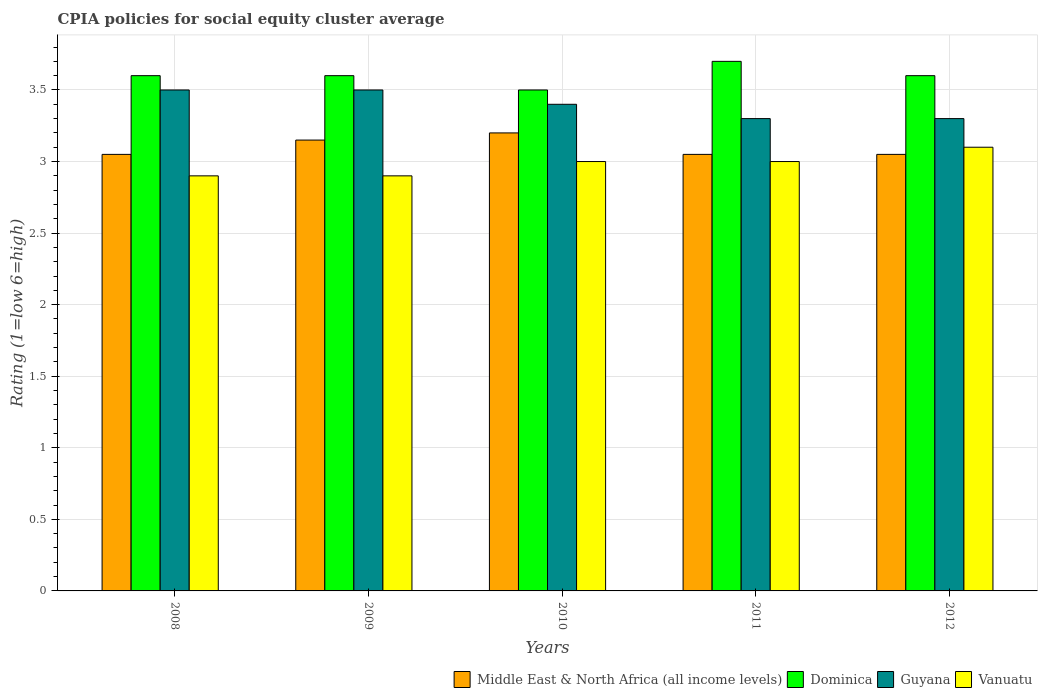How many groups of bars are there?
Your answer should be compact. 5. Are the number of bars on each tick of the X-axis equal?
Keep it short and to the point. Yes. How many bars are there on the 1st tick from the right?
Ensure brevity in your answer.  4. In how many cases, is the number of bars for a given year not equal to the number of legend labels?
Ensure brevity in your answer.  0. What is the CPIA rating in Middle East & North Africa (all income levels) in 2008?
Ensure brevity in your answer.  3.05. In which year was the CPIA rating in Middle East & North Africa (all income levels) minimum?
Your answer should be compact. 2008. What is the difference between the CPIA rating in Vanuatu in 2010 and that in 2011?
Your response must be concise. 0. What is the difference between the CPIA rating in Dominica in 2009 and the CPIA rating in Guyana in 2012?
Give a very brief answer. 0.3. In the year 2011, what is the difference between the CPIA rating in Dominica and CPIA rating in Middle East & North Africa (all income levels)?
Give a very brief answer. 0.65. In how many years, is the CPIA rating in Vanuatu greater than 1.6?
Give a very brief answer. 5. What is the ratio of the CPIA rating in Dominica in 2008 to that in 2009?
Offer a very short reply. 1. Is the CPIA rating in Dominica in 2008 less than that in 2011?
Make the answer very short. Yes. Is the difference between the CPIA rating in Dominica in 2010 and 2012 greater than the difference between the CPIA rating in Middle East & North Africa (all income levels) in 2010 and 2012?
Your answer should be compact. No. What is the difference between the highest and the lowest CPIA rating in Dominica?
Your response must be concise. 0.2. In how many years, is the CPIA rating in Guyana greater than the average CPIA rating in Guyana taken over all years?
Your response must be concise. 2. Is the sum of the CPIA rating in Dominica in 2011 and 2012 greater than the maximum CPIA rating in Middle East & North Africa (all income levels) across all years?
Provide a succinct answer. Yes. Is it the case that in every year, the sum of the CPIA rating in Dominica and CPIA rating in Vanuatu is greater than the sum of CPIA rating in Middle East & North Africa (all income levels) and CPIA rating in Guyana?
Give a very brief answer. Yes. What does the 4th bar from the left in 2011 represents?
Your response must be concise. Vanuatu. What does the 4th bar from the right in 2008 represents?
Offer a terse response. Middle East & North Africa (all income levels). How many bars are there?
Give a very brief answer. 20. Are all the bars in the graph horizontal?
Offer a terse response. No. How many years are there in the graph?
Keep it short and to the point. 5. What is the difference between two consecutive major ticks on the Y-axis?
Your answer should be compact. 0.5. How many legend labels are there?
Offer a very short reply. 4. What is the title of the graph?
Offer a very short reply. CPIA policies for social equity cluster average. Does "Estonia" appear as one of the legend labels in the graph?
Keep it short and to the point. No. What is the label or title of the X-axis?
Your answer should be very brief. Years. What is the Rating (1=low 6=high) of Middle East & North Africa (all income levels) in 2008?
Your answer should be compact. 3.05. What is the Rating (1=low 6=high) of Guyana in 2008?
Provide a short and direct response. 3.5. What is the Rating (1=low 6=high) of Middle East & North Africa (all income levels) in 2009?
Offer a very short reply. 3.15. What is the Rating (1=low 6=high) of Dominica in 2009?
Keep it short and to the point. 3.6. What is the Rating (1=low 6=high) in Vanuatu in 2009?
Keep it short and to the point. 2.9. What is the Rating (1=low 6=high) in Guyana in 2010?
Provide a short and direct response. 3.4. What is the Rating (1=low 6=high) in Middle East & North Africa (all income levels) in 2011?
Offer a terse response. 3.05. What is the Rating (1=low 6=high) in Dominica in 2011?
Provide a short and direct response. 3.7. What is the Rating (1=low 6=high) in Guyana in 2011?
Make the answer very short. 3.3. What is the Rating (1=low 6=high) in Middle East & North Africa (all income levels) in 2012?
Ensure brevity in your answer.  3.05. What is the Rating (1=low 6=high) in Guyana in 2012?
Your answer should be very brief. 3.3. What is the Rating (1=low 6=high) in Vanuatu in 2012?
Ensure brevity in your answer.  3.1. Across all years, what is the maximum Rating (1=low 6=high) of Guyana?
Ensure brevity in your answer.  3.5. Across all years, what is the minimum Rating (1=low 6=high) of Middle East & North Africa (all income levels)?
Offer a very short reply. 3.05. Across all years, what is the minimum Rating (1=low 6=high) in Dominica?
Your answer should be very brief. 3.5. Across all years, what is the minimum Rating (1=low 6=high) in Guyana?
Provide a short and direct response. 3.3. What is the total Rating (1=low 6=high) in Dominica in the graph?
Your answer should be compact. 18. What is the total Rating (1=low 6=high) of Vanuatu in the graph?
Ensure brevity in your answer.  14.9. What is the difference between the Rating (1=low 6=high) in Guyana in 2008 and that in 2009?
Keep it short and to the point. 0. What is the difference between the Rating (1=low 6=high) in Vanuatu in 2008 and that in 2009?
Make the answer very short. 0. What is the difference between the Rating (1=low 6=high) in Dominica in 2008 and that in 2010?
Offer a very short reply. 0.1. What is the difference between the Rating (1=low 6=high) of Vanuatu in 2008 and that in 2010?
Your answer should be very brief. -0.1. What is the difference between the Rating (1=low 6=high) in Dominica in 2008 and that in 2011?
Your answer should be very brief. -0.1. What is the difference between the Rating (1=low 6=high) of Dominica in 2008 and that in 2012?
Your answer should be compact. 0. What is the difference between the Rating (1=low 6=high) of Vanuatu in 2008 and that in 2012?
Offer a very short reply. -0.2. What is the difference between the Rating (1=low 6=high) in Middle East & North Africa (all income levels) in 2009 and that in 2010?
Make the answer very short. -0.05. What is the difference between the Rating (1=low 6=high) of Vanuatu in 2009 and that in 2010?
Your answer should be very brief. -0.1. What is the difference between the Rating (1=low 6=high) in Guyana in 2009 and that in 2011?
Your response must be concise. 0.2. What is the difference between the Rating (1=low 6=high) of Vanuatu in 2009 and that in 2011?
Keep it short and to the point. -0.1. What is the difference between the Rating (1=low 6=high) in Middle East & North Africa (all income levels) in 2009 and that in 2012?
Your response must be concise. 0.1. What is the difference between the Rating (1=low 6=high) of Dominica in 2009 and that in 2012?
Make the answer very short. 0. What is the difference between the Rating (1=low 6=high) of Guyana in 2009 and that in 2012?
Offer a very short reply. 0.2. What is the difference between the Rating (1=low 6=high) in Dominica in 2010 and that in 2011?
Offer a terse response. -0.2. What is the difference between the Rating (1=low 6=high) of Guyana in 2010 and that in 2011?
Offer a very short reply. 0.1. What is the difference between the Rating (1=low 6=high) in Vanuatu in 2010 and that in 2011?
Give a very brief answer. 0. What is the difference between the Rating (1=low 6=high) of Middle East & North Africa (all income levels) in 2010 and that in 2012?
Your response must be concise. 0.15. What is the difference between the Rating (1=low 6=high) in Guyana in 2010 and that in 2012?
Offer a terse response. 0.1. What is the difference between the Rating (1=low 6=high) of Middle East & North Africa (all income levels) in 2011 and that in 2012?
Provide a short and direct response. 0. What is the difference between the Rating (1=low 6=high) in Dominica in 2011 and that in 2012?
Your answer should be compact. 0.1. What is the difference between the Rating (1=low 6=high) in Guyana in 2011 and that in 2012?
Ensure brevity in your answer.  0. What is the difference between the Rating (1=low 6=high) in Vanuatu in 2011 and that in 2012?
Ensure brevity in your answer.  -0.1. What is the difference between the Rating (1=low 6=high) of Middle East & North Africa (all income levels) in 2008 and the Rating (1=low 6=high) of Dominica in 2009?
Provide a short and direct response. -0.55. What is the difference between the Rating (1=low 6=high) in Middle East & North Africa (all income levels) in 2008 and the Rating (1=low 6=high) in Guyana in 2009?
Offer a very short reply. -0.45. What is the difference between the Rating (1=low 6=high) in Dominica in 2008 and the Rating (1=low 6=high) in Guyana in 2009?
Your response must be concise. 0.1. What is the difference between the Rating (1=low 6=high) in Dominica in 2008 and the Rating (1=low 6=high) in Vanuatu in 2009?
Ensure brevity in your answer.  0.7. What is the difference between the Rating (1=low 6=high) of Middle East & North Africa (all income levels) in 2008 and the Rating (1=low 6=high) of Dominica in 2010?
Ensure brevity in your answer.  -0.45. What is the difference between the Rating (1=low 6=high) in Middle East & North Africa (all income levels) in 2008 and the Rating (1=low 6=high) in Guyana in 2010?
Your answer should be compact. -0.35. What is the difference between the Rating (1=low 6=high) of Dominica in 2008 and the Rating (1=low 6=high) of Vanuatu in 2010?
Give a very brief answer. 0.6. What is the difference between the Rating (1=low 6=high) in Guyana in 2008 and the Rating (1=low 6=high) in Vanuatu in 2010?
Your answer should be very brief. 0.5. What is the difference between the Rating (1=low 6=high) of Middle East & North Africa (all income levels) in 2008 and the Rating (1=low 6=high) of Dominica in 2011?
Your answer should be very brief. -0.65. What is the difference between the Rating (1=low 6=high) of Middle East & North Africa (all income levels) in 2008 and the Rating (1=low 6=high) of Guyana in 2011?
Provide a short and direct response. -0.25. What is the difference between the Rating (1=low 6=high) of Dominica in 2008 and the Rating (1=low 6=high) of Vanuatu in 2011?
Offer a very short reply. 0.6. What is the difference between the Rating (1=low 6=high) in Middle East & North Africa (all income levels) in 2008 and the Rating (1=low 6=high) in Dominica in 2012?
Provide a short and direct response. -0.55. What is the difference between the Rating (1=low 6=high) in Middle East & North Africa (all income levels) in 2008 and the Rating (1=low 6=high) in Vanuatu in 2012?
Your answer should be very brief. -0.05. What is the difference between the Rating (1=low 6=high) of Guyana in 2008 and the Rating (1=low 6=high) of Vanuatu in 2012?
Make the answer very short. 0.4. What is the difference between the Rating (1=low 6=high) in Middle East & North Africa (all income levels) in 2009 and the Rating (1=low 6=high) in Dominica in 2010?
Provide a succinct answer. -0.35. What is the difference between the Rating (1=low 6=high) in Middle East & North Africa (all income levels) in 2009 and the Rating (1=low 6=high) in Vanuatu in 2010?
Your answer should be very brief. 0.15. What is the difference between the Rating (1=low 6=high) of Middle East & North Africa (all income levels) in 2009 and the Rating (1=low 6=high) of Dominica in 2011?
Ensure brevity in your answer.  -0.55. What is the difference between the Rating (1=low 6=high) in Guyana in 2009 and the Rating (1=low 6=high) in Vanuatu in 2011?
Keep it short and to the point. 0.5. What is the difference between the Rating (1=low 6=high) in Middle East & North Africa (all income levels) in 2009 and the Rating (1=low 6=high) in Dominica in 2012?
Your response must be concise. -0.45. What is the difference between the Rating (1=low 6=high) of Middle East & North Africa (all income levels) in 2009 and the Rating (1=low 6=high) of Guyana in 2012?
Make the answer very short. -0.15. What is the difference between the Rating (1=low 6=high) of Dominica in 2009 and the Rating (1=low 6=high) of Guyana in 2012?
Your answer should be very brief. 0.3. What is the difference between the Rating (1=low 6=high) of Dominica in 2009 and the Rating (1=low 6=high) of Vanuatu in 2012?
Make the answer very short. 0.5. What is the difference between the Rating (1=low 6=high) of Middle East & North Africa (all income levels) in 2010 and the Rating (1=low 6=high) of Vanuatu in 2011?
Your answer should be very brief. 0.2. What is the difference between the Rating (1=low 6=high) of Guyana in 2010 and the Rating (1=low 6=high) of Vanuatu in 2011?
Your answer should be compact. 0.4. What is the difference between the Rating (1=low 6=high) of Middle East & North Africa (all income levels) in 2010 and the Rating (1=low 6=high) of Dominica in 2012?
Your answer should be compact. -0.4. What is the difference between the Rating (1=low 6=high) in Middle East & North Africa (all income levels) in 2010 and the Rating (1=low 6=high) in Guyana in 2012?
Make the answer very short. -0.1. What is the difference between the Rating (1=low 6=high) of Dominica in 2010 and the Rating (1=low 6=high) of Guyana in 2012?
Offer a terse response. 0.2. What is the difference between the Rating (1=low 6=high) of Middle East & North Africa (all income levels) in 2011 and the Rating (1=low 6=high) of Dominica in 2012?
Your answer should be very brief. -0.55. What is the difference between the Rating (1=low 6=high) of Middle East & North Africa (all income levels) in 2011 and the Rating (1=low 6=high) of Vanuatu in 2012?
Give a very brief answer. -0.05. What is the difference between the Rating (1=low 6=high) of Dominica in 2011 and the Rating (1=low 6=high) of Guyana in 2012?
Offer a terse response. 0.4. What is the difference between the Rating (1=low 6=high) of Dominica in 2011 and the Rating (1=low 6=high) of Vanuatu in 2012?
Your answer should be very brief. 0.6. What is the average Rating (1=low 6=high) in Middle East & North Africa (all income levels) per year?
Ensure brevity in your answer.  3.1. What is the average Rating (1=low 6=high) of Dominica per year?
Make the answer very short. 3.6. What is the average Rating (1=low 6=high) of Vanuatu per year?
Your response must be concise. 2.98. In the year 2008, what is the difference between the Rating (1=low 6=high) of Middle East & North Africa (all income levels) and Rating (1=low 6=high) of Dominica?
Give a very brief answer. -0.55. In the year 2008, what is the difference between the Rating (1=low 6=high) in Middle East & North Africa (all income levels) and Rating (1=low 6=high) in Guyana?
Offer a very short reply. -0.45. In the year 2008, what is the difference between the Rating (1=low 6=high) in Dominica and Rating (1=low 6=high) in Guyana?
Keep it short and to the point. 0.1. In the year 2008, what is the difference between the Rating (1=low 6=high) in Dominica and Rating (1=low 6=high) in Vanuatu?
Your answer should be very brief. 0.7. In the year 2008, what is the difference between the Rating (1=low 6=high) in Guyana and Rating (1=low 6=high) in Vanuatu?
Your answer should be compact. 0.6. In the year 2009, what is the difference between the Rating (1=low 6=high) of Middle East & North Africa (all income levels) and Rating (1=low 6=high) of Dominica?
Give a very brief answer. -0.45. In the year 2009, what is the difference between the Rating (1=low 6=high) in Middle East & North Africa (all income levels) and Rating (1=low 6=high) in Guyana?
Your response must be concise. -0.35. In the year 2009, what is the difference between the Rating (1=low 6=high) in Dominica and Rating (1=low 6=high) in Guyana?
Provide a succinct answer. 0.1. In the year 2009, what is the difference between the Rating (1=low 6=high) of Guyana and Rating (1=low 6=high) of Vanuatu?
Provide a succinct answer. 0.6. In the year 2010, what is the difference between the Rating (1=low 6=high) of Middle East & North Africa (all income levels) and Rating (1=low 6=high) of Vanuatu?
Your response must be concise. 0.2. In the year 2010, what is the difference between the Rating (1=low 6=high) in Guyana and Rating (1=low 6=high) in Vanuatu?
Your answer should be compact. 0.4. In the year 2011, what is the difference between the Rating (1=low 6=high) in Middle East & North Africa (all income levels) and Rating (1=low 6=high) in Dominica?
Make the answer very short. -0.65. In the year 2011, what is the difference between the Rating (1=low 6=high) of Middle East & North Africa (all income levels) and Rating (1=low 6=high) of Guyana?
Ensure brevity in your answer.  -0.25. In the year 2011, what is the difference between the Rating (1=low 6=high) in Middle East & North Africa (all income levels) and Rating (1=low 6=high) in Vanuatu?
Give a very brief answer. 0.05. In the year 2011, what is the difference between the Rating (1=low 6=high) in Dominica and Rating (1=low 6=high) in Vanuatu?
Your response must be concise. 0.7. In the year 2011, what is the difference between the Rating (1=low 6=high) of Guyana and Rating (1=low 6=high) of Vanuatu?
Make the answer very short. 0.3. In the year 2012, what is the difference between the Rating (1=low 6=high) in Middle East & North Africa (all income levels) and Rating (1=low 6=high) in Dominica?
Your response must be concise. -0.55. In the year 2012, what is the difference between the Rating (1=low 6=high) in Middle East & North Africa (all income levels) and Rating (1=low 6=high) in Vanuatu?
Offer a very short reply. -0.05. In the year 2012, what is the difference between the Rating (1=low 6=high) of Guyana and Rating (1=low 6=high) of Vanuatu?
Ensure brevity in your answer.  0.2. What is the ratio of the Rating (1=low 6=high) in Middle East & North Africa (all income levels) in 2008 to that in 2009?
Make the answer very short. 0.97. What is the ratio of the Rating (1=low 6=high) in Dominica in 2008 to that in 2009?
Your answer should be very brief. 1. What is the ratio of the Rating (1=low 6=high) in Middle East & North Africa (all income levels) in 2008 to that in 2010?
Your answer should be very brief. 0.95. What is the ratio of the Rating (1=low 6=high) in Dominica in 2008 to that in 2010?
Your answer should be very brief. 1.03. What is the ratio of the Rating (1=low 6=high) in Guyana in 2008 to that in 2010?
Your response must be concise. 1.03. What is the ratio of the Rating (1=low 6=high) in Vanuatu in 2008 to that in 2010?
Give a very brief answer. 0.97. What is the ratio of the Rating (1=low 6=high) in Middle East & North Africa (all income levels) in 2008 to that in 2011?
Give a very brief answer. 1. What is the ratio of the Rating (1=low 6=high) in Dominica in 2008 to that in 2011?
Offer a very short reply. 0.97. What is the ratio of the Rating (1=low 6=high) in Guyana in 2008 to that in 2011?
Give a very brief answer. 1.06. What is the ratio of the Rating (1=low 6=high) in Vanuatu in 2008 to that in 2011?
Give a very brief answer. 0.97. What is the ratio of the Rating (1=low 6=high) of Middle East & North Africa (all income levels) in 2008 to that in 2012?
Offer a very short reply. 1. What is the ratio of the Rating (1=low 6=high) of Guyana in 2008 to that in 2012?
Your response must be concise. 1.06. What is the ratio of the Rating (1=low 6=high) of Vanuatu in 2008 to that in 2012?
Your answer should be very brief. 0.94. What is the ratio of the Rating (1=low 6=high) of Middle East & North Africa (all income levels) in 2009 to that in 2010?
Your answer should be compact. 0.98. What is the ratio of the Rating (1=low 6=high) of Dominica in 2009 to that in 2010?
Offer a terse response. 1.03. What is the ratio of the Rating (1=low 6=high) of Guyana in 2009 to that in 2010?
Provide a short and direct response. 1.03. What is the ratio of the Rating (1=low 6=high) of Vanuatu in 2009 to that in 2010?
Your answer should be compact. 0.97. What is the ratio of the Rating (1=low 6=high) of Middle East & North Africa (all income levels) in 2009 to that in 2011?
Your answer should be very brief. 1.03. What is the ratio of the Rating (1=low 6=high) of Dominica in 2009 to that in 2011?
Provide a short and direct response. 0.97. What is the ratio of the Rating (1=low 6=high) in Guyana in 2009 to that in 2011?
Offer a very short reply. 1.06. What is the ratio of the Rating (1=low 6=high) of Vanuatu in 2009 to that in 2011?
Keep it short and to the point. 0.97. What is the ratio of the Rating (1=low 6=high) in Middle East & North Africa (all income levels) in 2009 to that in 2012?
Your answer should be very brief. 1.03. What is the ratio of the Rating (1=low 6=high) in Guyana in 2009 to that in 2012?
Make the answer very short. 1.06. What is the ratio of the Rating (1=low 6=high) of Vanuatu in 2009 to that in 2012?
Your answer should be very brief. 0.94. What is the ratio of the Rating (1=low 6=high) in Middle East & North Africa (all income levels) in 2010 to that in 2011?
Keep it short and to the point. 1.05. What is the ratio of the Rating (1=low 6=high) in Dominica in 2010 to that in 2011?
Your answer should be very brief. 0.95. What is the ratio of the Rating (1=low 6=high) of Guyana in 2010 to that in 2011?
Give a very brief answer. 1.03. What is the ratio of the Rating (1=low 6=high) of Middle East & North Africa (all income levels) in 2010 to that in 2012?
Your answer should be very brief. 1.05. What is the ratio of the Rating (1=low 6=high) in Dominica in 2010 to that in 2012?
Your response must be concise. 0.97. What is the ratio of the Rating (1=low 6=high) of Guyana in 2010 to that in 2012?
Give a very brief answer. 1.03. What is the ratio of the Rating (1=low 6=high) in Dominica in 2011 to that in 2012?
Provide a short and direct response. 1.03. What is the ratio of the Rating (1=low 6=high) in Guyana in 2011 to that in 2012?
Provide a short and direct response. 1. What is the difference between the highest and the second highest Rating (1=low 6=high) in Middle East & North Africa (all income levels)?
Provide a succinct answer. 0.05. What is the difference between the highest and the second highest Rating (1=low 6=high) of Vanuatu?
Make the answer very short. 0.1. What is the difference between the highest and the lowest Rating (1=low 6=high) of Middle East & North Africa (all income levels)?
Give a very brief answer. 0.15. What is the difference between the highest and the lowest Rating (1=low 6=high) of Vanuatu?
Provide a succinct answer. 0.2. 